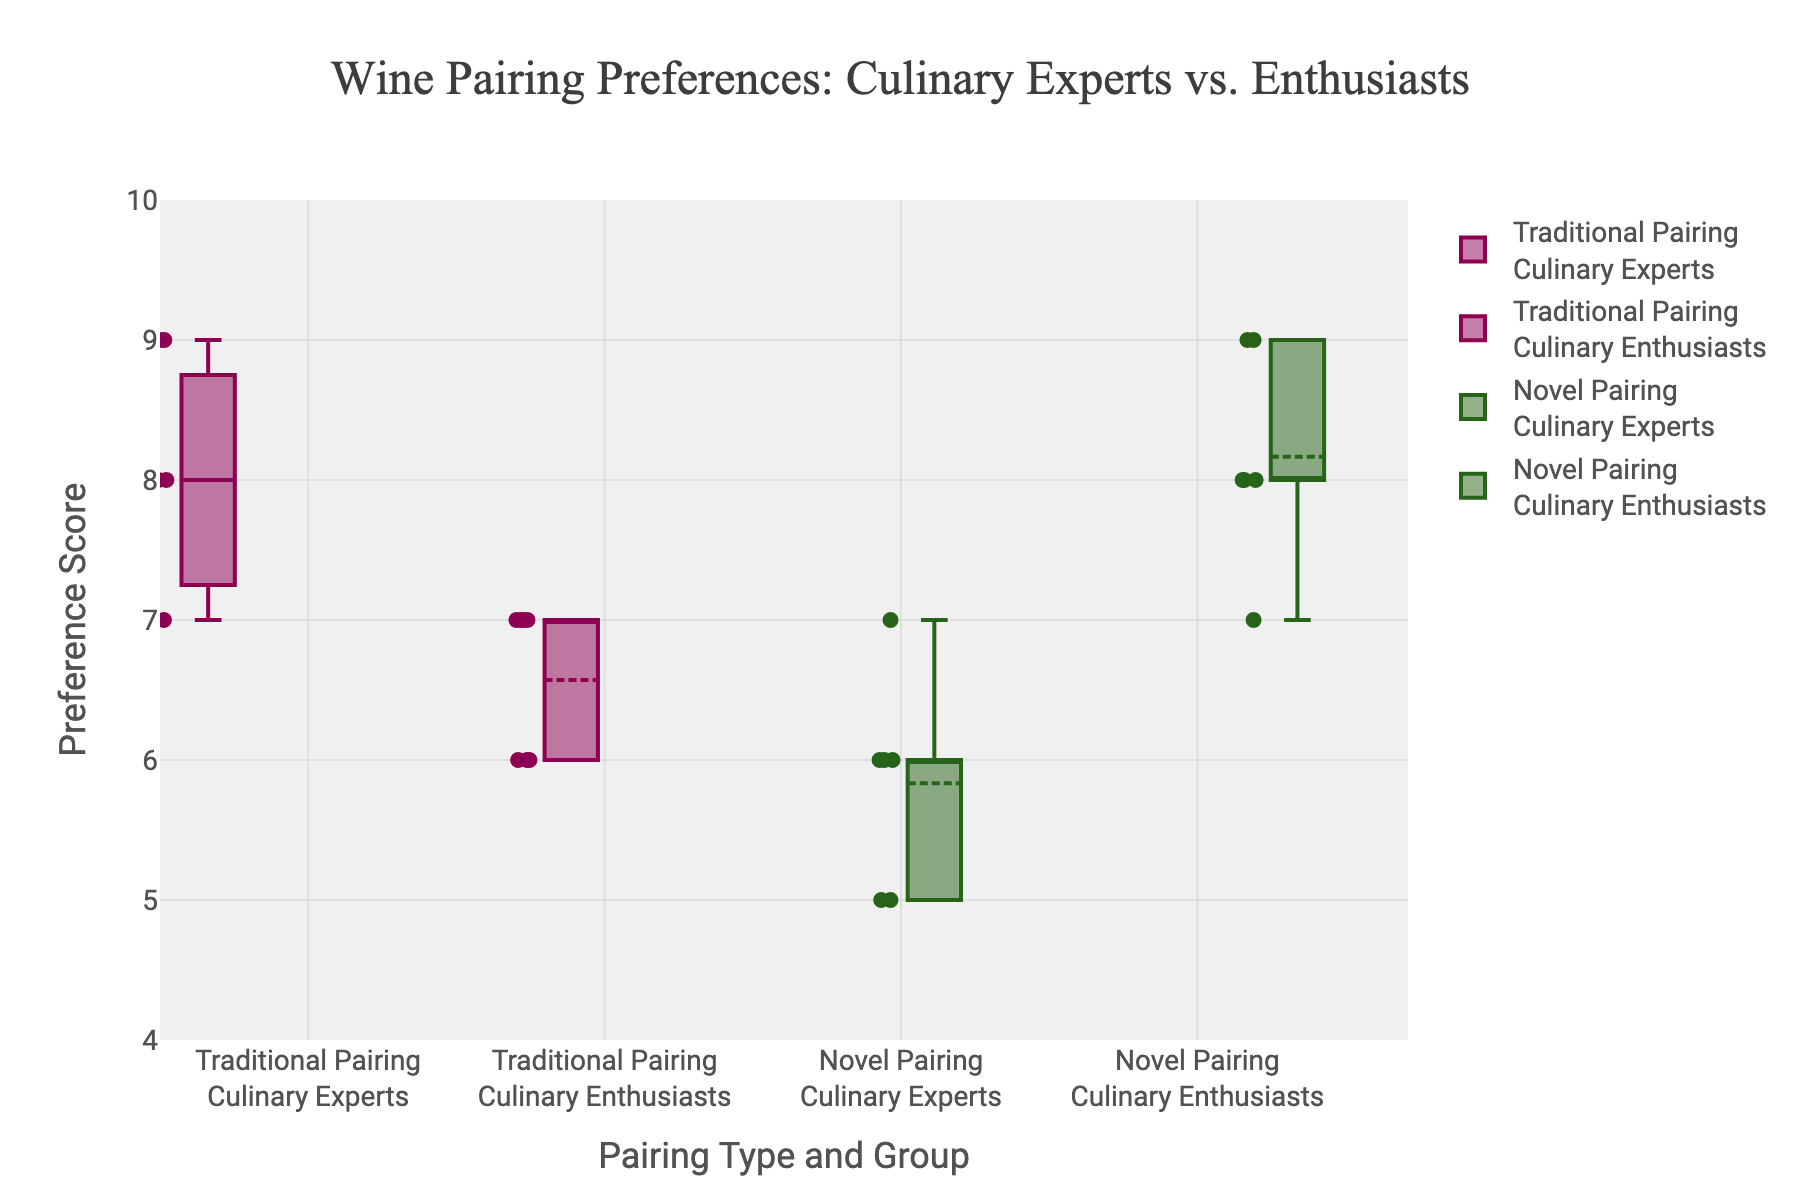What is the title of the figure? The title is usually located at the top of the figure. It provides a summary of what the figure represents.
Answer: Wine Pairing Preferences: Culinary Experts vs. Enthusiasts What are the two groups compared in the figure? The figure compares two groups, which are shown in the box labels. These groups are Culinary Experts and Culinary Enthusiasts.
Answer: Culinary Experts and Culinary Enthusiasts What are the two types of pairings shown in the figure? Looking at the box labels again, we can see two types of pairings: Traditional Pairing and Novel Pairing.
Answer: Traditional Pairing and Novel Pairing What is the range of the y-axis in the figure? The y-axis range can be determined by looking at the values marked on the y-axis. The range starts from 4 and goes up to 10.
Answer: 4 to 10 Which group shows the highest median value for Novel Pairing? To find the highest median value, we need to compare the medians of Culinary Experts and Culinary Enthusiasts for Novel Pairing. Culinary Enthusiasts have the higher median.
Answer: Culinary Enthusiasts How many data points are there for Traditional Pairing in the Culinary Experts group? Each data point shown in the box represents the number of values. Counting the points inside the box for Traditional Pairing in the Culinary Experts group gives us 7 data points.
Answer: 7 Which pairing type has a higher mean value for Culinary Experts? To compare the mean values, we look for the mean lines inside the boxes. Traditional Pairing for Culinary Experts has a higher mean value than Novel Pairing.
Answer: Traditional Pairing What is the median value for Traditional Pairing among Culinary Enthusiasts? The median value is represented by the line inside the box. For Traditional Pairing among Culinary Enthusiasts, the median line is at 7.
Answer: 7 Which group shows greater variability in their preference scores for Novel Pairing? Variability can be judged by the length of the box and the whiskers. For Novel Pairing, Culinary Enthusiasts show greater variability than Culinary Experts.
Answer: Culinary Enthusiasts What is the difference between the median values of Traditional Pairing and Novel Pairing for Culinary Experts? First, identify the median values of each: Traditional Pairing is 8 and Novel Pairing is 6. The difference is 8 - 6 = 2.
Answer: 2 